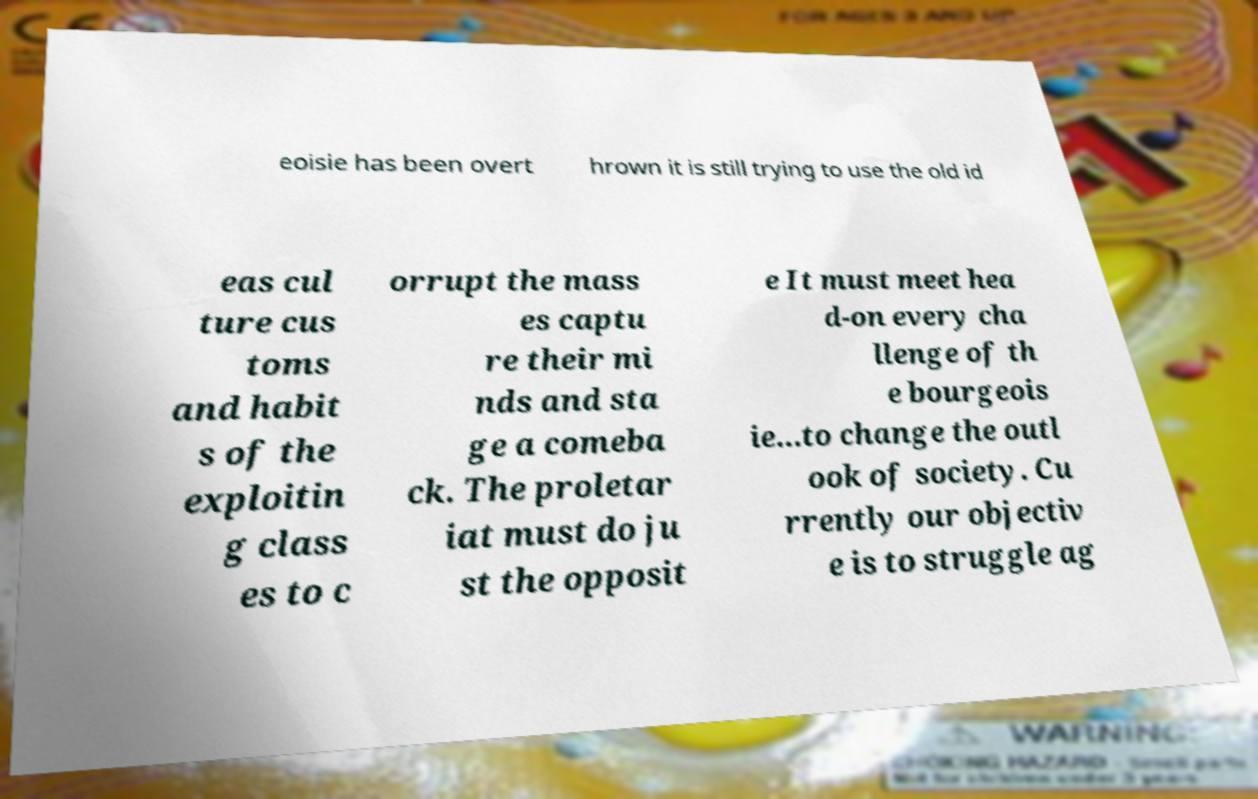Could you extract and type out the text from this image? eoisie has been overt hrown it is still trying to use the old id eas cul ture cus toms and habit s of the exploitin g class es to c orrupt the mass es captu re their mi nds and sta ge a comeba ck. The proletar iat must do ju st the opposit e It must meet hea d-on every cha llenge of th e bourgeois ie...to change the outl ook of society. Cu rrently our objectiv e is to struggle ag 